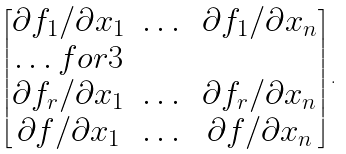Convert formula to latex. <formula><loc_0><loc_0><loc_500><loc_500>\begin{bmatrix} \partial f _ { 1 } / \partial x _ { 1 } & \dots & \partial f _ { 1 } / \partial x _ { n } \\ \hdots f o r { 3 } \\ \partial f _ { r } / \partial x _ { 1 } & \dots & \partial f _ { r } / \partial x _ { n } \\ \partial f / \partial x _ { 1 } & \dots & \partial f / \partial x _ { n } \end{bmatrix} .</formula> 